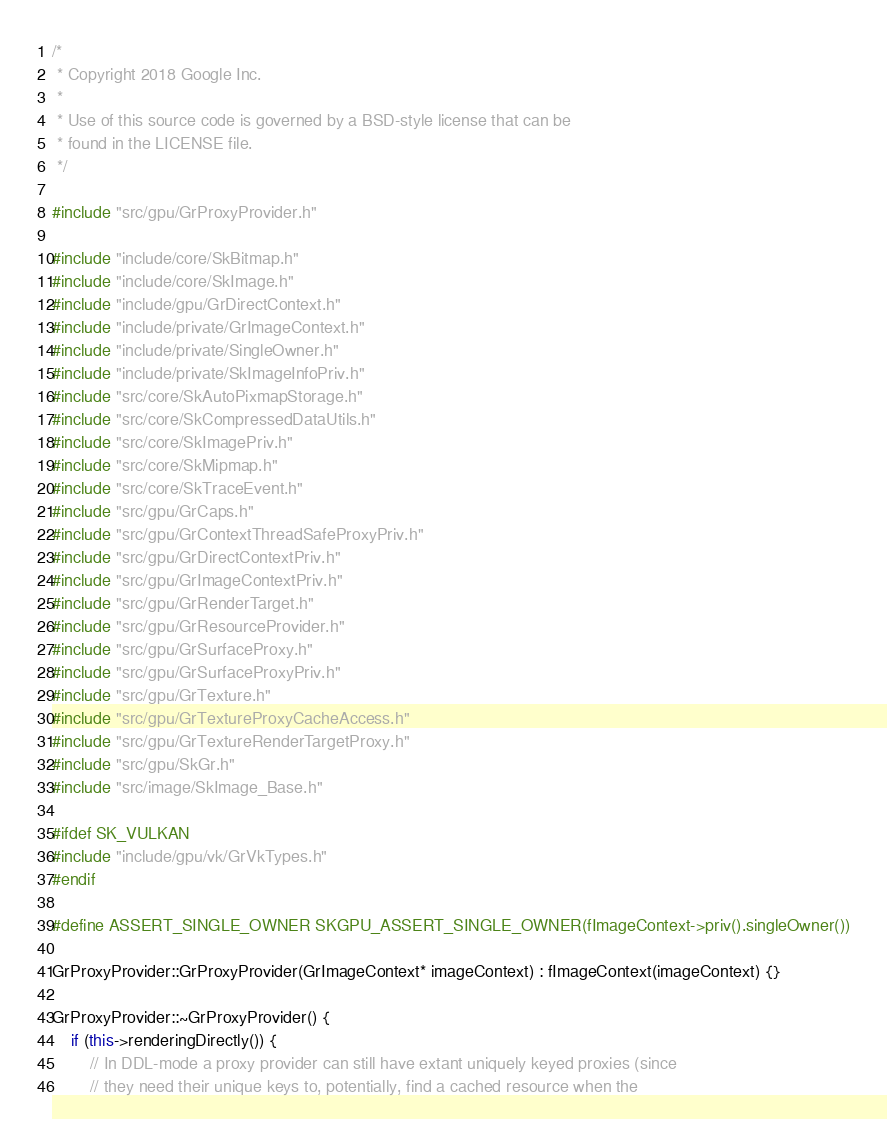<code> <loc_0><loc_0><loc_500><loc_500><_C++_>/*
 * Copyright 2018 Google Inc.
 *
 * Use of this source code is governed by a BSD-style license that can be
 * found in the LICENSE file.
 */

#include "src/gpu/GrProxyProvider.h"

#include "include/core/SkBitmap.h"
#include "include/core/SkImage.h"
#include "include/gpu/GrDirectContext.h"
#include "include/private/GrImageContext.h"
#include "include/private/SingleOwner.h"
#include "include/private/SkImageInfoPriv.h"
#include "src/core/SkAutoPixmapStorage.h"
#include "src/core/SkCompressedDataUtils.h"
#include "src/core/SkImagePriv.h"
#include "src/core/SkMipmap.h"
#include "src/core/SkTraceEvent.h"
#include "src/gpu/GrCaps.h"
#include "src/gpu/GrContextThreadSafeProxyPriv.h"
#include "src/gpu/GrDirectContextPriv.h"
#include "src/gpu/GrImageContextPriv.h"
#include "src/gpu/GrRenderTarget.h"
#include "src/gpu/GrResourceProvider.h"
#include "src/gpu/GrSurfaceProxy.h"
#include "src/gpu/GrSurfaceProxyPriv.h"
#include "src/gpu/GrTexture.h"
#include "src/gpu/GrTextureProxyCacheAccess.h"
#include "src/gpu/GrTextureRenderTargetProxy.h"
#include "src/gpu/SkGr.h"
#include "src/image/SkImage_Base.h"

#ifdef SK_VULKAN
#include "include/gpu/vk/GrVkTypes.h"
#endif

#define ASSERT_SINGLE_OWNER SKGPU_ASSERT_SINGLE_OWNER(fImageContext->priv().singleOwner())

GrProxyProvider::GrProxyProvider(GrImageContext* imageContext) : fImageContext(imageContext) {}

GrProxyProvider::~GrProxyProvider() {
    if (this->renderingDirectly()) {
        // In DDL-mode a proxy provider can still have extant uniquely keyed proxies (since
        // they need their unique keys to, potentially, find a cached resource when the</code> 